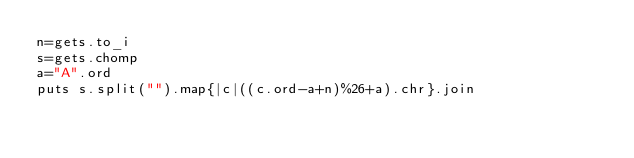Convert code to text. <code><loc_0><loc_0><loc_500><loc_500><_Ruby_>n=gets.to_i
s=gets.chomp
a="A".ord
puts s.split("").map{|c|((c.ord-a+n)%26+a).chr}.join</code> 